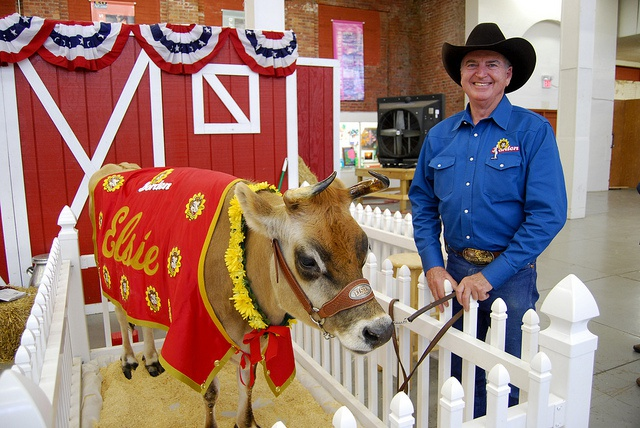Describe the objects in this image and their specific colors. I can see cow in maroon, brown, olive, and tan tones, people in maroon, blue, navy, black, and brown tones, and dining table in maroon, olive, tan, and darkgray tones in this image. 